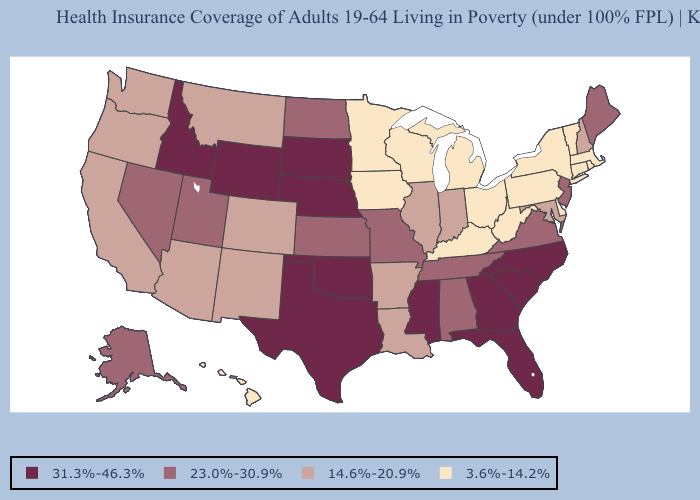Is the legend a continuous bar?
Write a very short answer. No. Among the states that border Virginia , does Tennessee have the lowest value?
Give a very brief answer. No. What is the value of Ohio?
Quick response, please. 3.6%-14.2%. Among the states that border Oregon , does Washington have the lowest value?
Answer briefly. Yes. What is the value of Utah?
Short answer required. 23.0%-30.9%. Does Vermont have the lowest value in the Northeast?
Concise answer only. Yes. What is the value of Illinois?
Short answer required. 14.6%-20.9%. Does Kentucky have the highest value in the USA?
Keep it brief. No. Which states hav the highest value in the MidWest?
Short answer required. Nebraska, South Dakota. What is the value of Hawaii?
Be succinct. 3.6%-14.2%. Among the states that border Georgia , does North Carolina have the lowest value?
Keep it brief. No. Name the states that have a value in the range 31.3%-46.3%?
Short answer required. Florida, Georgia, Idaho, Mississippi, Nebraska, North Carolina, Oklahoma, South Carolina, South Dakota, Texas, Wyoming. What is the value of Florida?
Short answer required. 31.3%-46.3%. What is the lowest value in the USA?
Short answer required. 3.6%-14.2%. Which states hav the highest value in the MidWest?
Write a very short answer. Nebraska, South Dakota. 